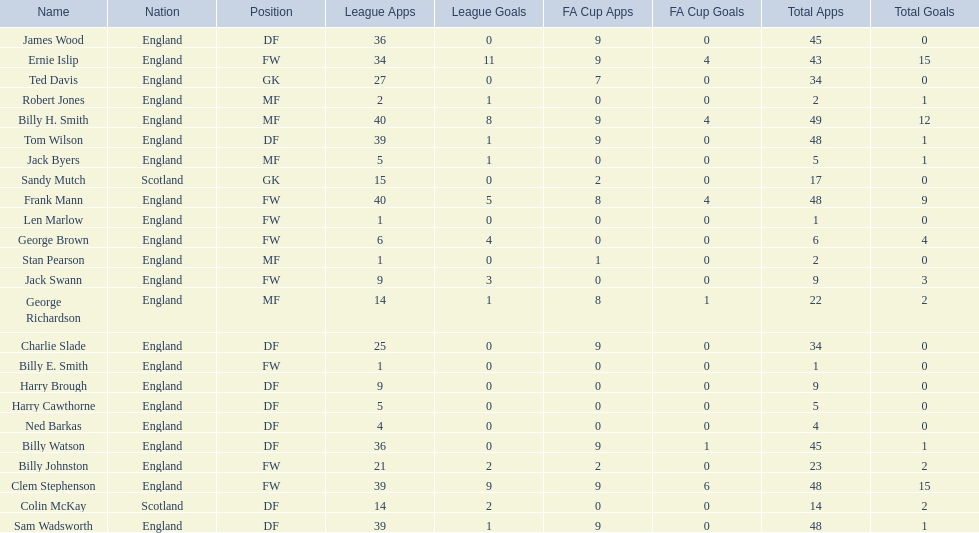What is the first name listed? Ned Barkas. 